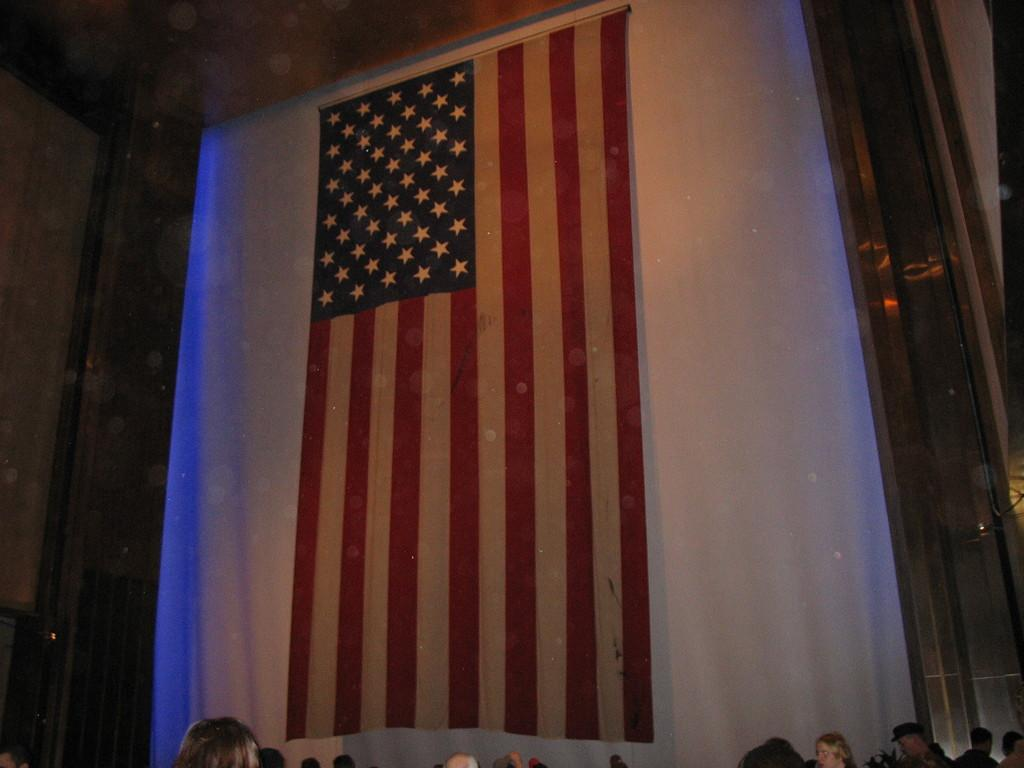How many people are in the image? There are persons in the image, but the exact number cannot be determined from the provided facts. What is the other main subject in the image besides the persons? There is a flag in the image. What color are the eyes of the goat in the image? There is no goat present in the image, so the color of its eyes cannot be determined. 